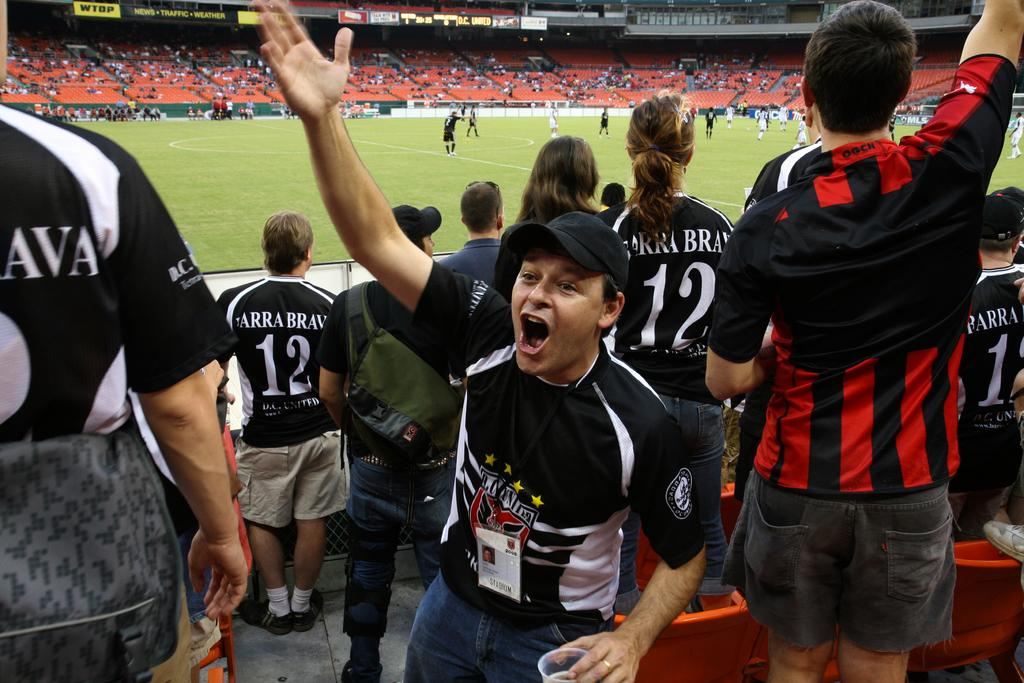<image>
Relay a brief, clear account of the picture shown. a fan with the number 12 on their shirt 